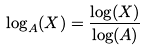Convert formula to latex. <formula><loc_0><loc_0><loc_500><loc_500>\log _ { A } ( X ) = \frac { \log ( X ) } { \log ( A ) }</formula> 